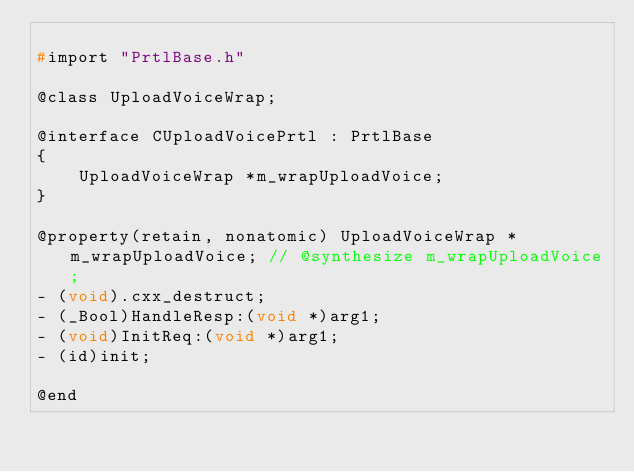<code> <loc_0><loc_0><loc_500><loc_500><_C_>
#import "PrtlBase.h"

@class UploadVoiceWrap;

@interface CUploadVoicePrtl : PrtlBase
{
    UploadVoiceWrap *m_wrapUploadVoice;
}

@property(retain, nonatomic) UploadVoiceWrap *m_wrapUploadVoice; // @synthesize m_wrapUploadVoice;
- (void).cxx_destruct;
- (_Bool)HandleResp:(void *)arg1;
- (void)InitReq:(void *)arg1;
- (id)init;

@end

</code> 